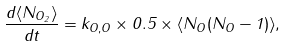Convert formula to latex. <formula><loc_0><loc_0><loc_500><loc_500>\frac { { d \langle N _ { O _ { 2 } } \rangle } } { d t } = k _ { O , O } \times 0 . 5 \times \langle N _ { O } ( N _ { O } - 1 ) \rangle ,</formula> 